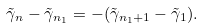<formula> <loc_0><loc_0><loc_500><loc_500>\tilde { \gamma } _ { n } - \tilde { \gamma } _ { n _ { 1 } } = - ( \tilde { \gamma } _ { n _ { 1 } + 1 } - \tilde { \gamma } _ { 1 } ) .</formula> 